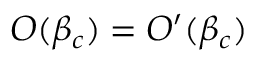Convert formula to latex. <formula><loc_0><loc_0><loc_500><loc_500>O ( \beta _ { c } ) = O ^ { \prime } ( \beta _ { c } )</formula> 